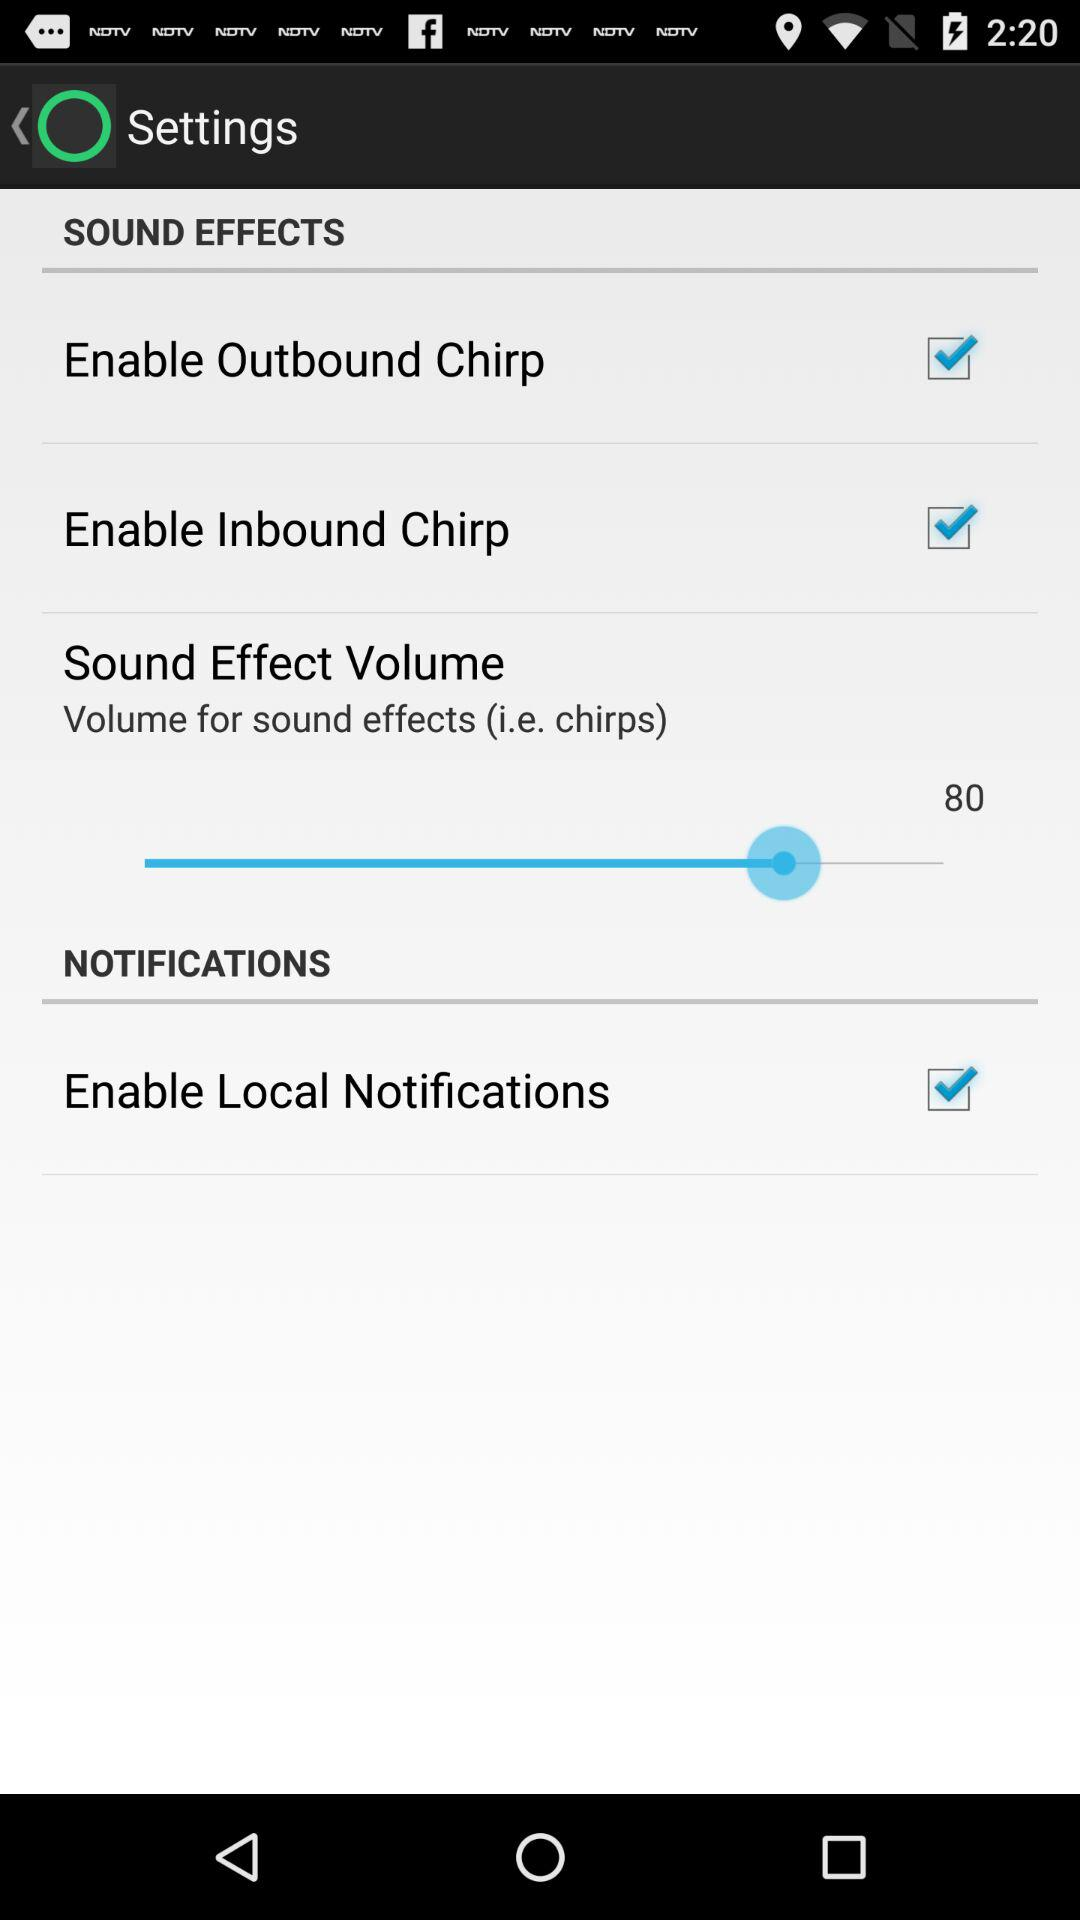What is the status of "Enable Local Notifications"? The status is "on". 